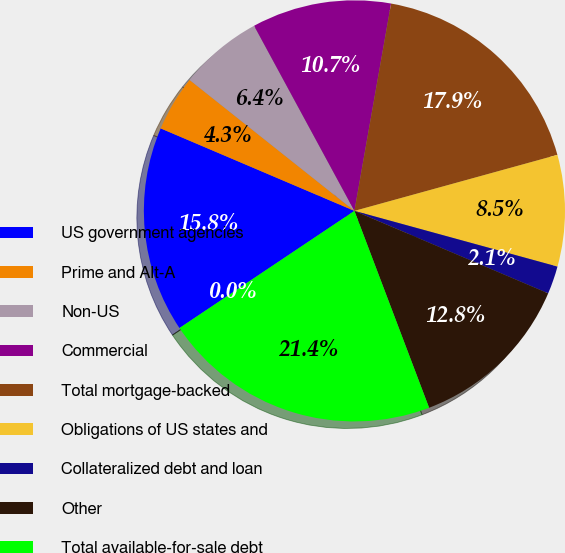Convert chart. <chart><loc_0><loc_0><loc_500><loc_500><pie_chart><fcel>US government agencies<fcel>Prime and Alt-A<fcel>Non-US<fcel>Commercial<fcel>Total mortgage-backed<fcel>Obligations of US states and<fcel>Collateralized debt and loan<fcel>Other<fcel>Total available-for-sale debt<fcel>Available-for-sale equity<nl><fcel>15.8%<fcel>4.28%<fcel>6.41%<fcel>10.69%<fcel>17.93%<fcel>8.55%<fcel>2.14%<fcel>12.83%<fcel>21.38%<fcel>0.0%<nl></chart> 